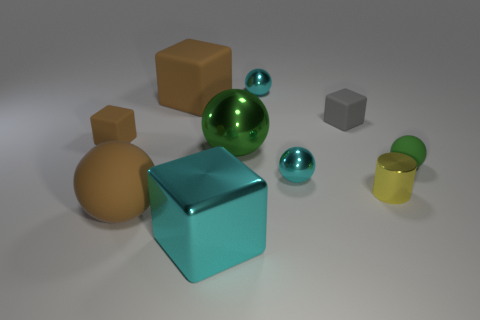Subtract all gray matte blocks. How many blocks are left? 3 Subtract all gray cylinders. How many brown cubes are left? 2 Subtract all cyan blocks. How many blocks are left? 3 Subtract all cylinders. How many objects are left? 9 Subtract all gray spheres. Subtract all red cylinders. How many spheres are left? 5 Subtract all yellow blocks. Subtract all small gray matte blocks. How many objects are left? 9 Add 5 big cyan metallic objects. How many big cyan metallic objects are left? 6 Add 7 big brown matte things. How many big brown matte things exist? 9 Subtract 0 purple balls. How many objects are left? 10 